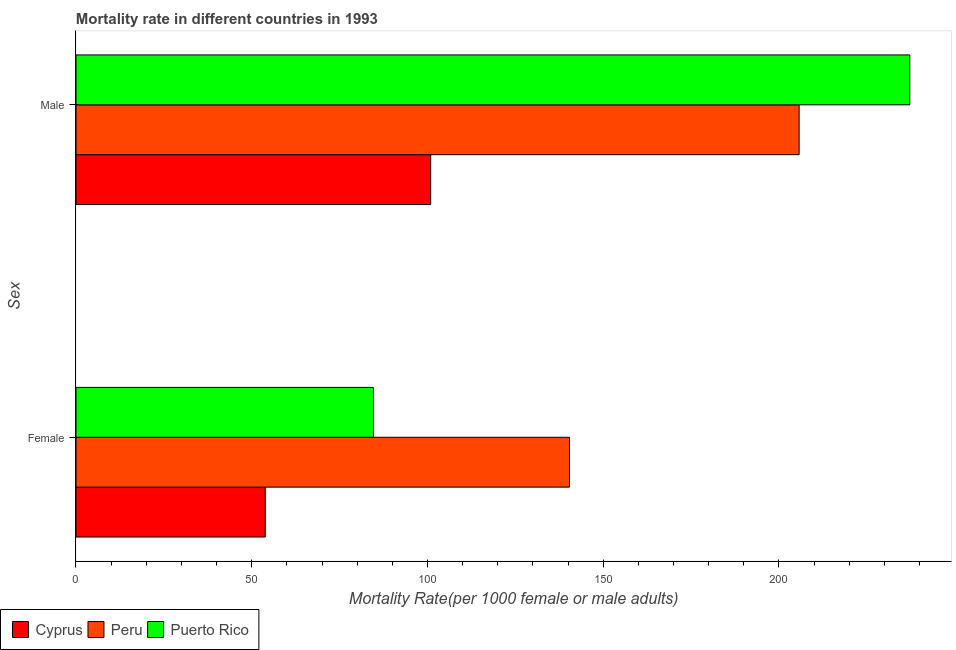Are the number of bars per tick equal to the number of legend labels?
Keep it short and to the point. Yes. Are the number of bars on each tick of the Y-axis equal?
Your answer should be compact. Yes. How many bars are there on the 1st tick from the bottom?
Your answer should be very brief. 3. What is the label of the 2nd group of bars from the top?
Make the answer very short. Female. What is the female mortality rate in Cyprus?
Ensure brevity in your answer.  53.86. Across all countries, what is the maximum male mortality rate?
Your response must be concise. 237.24. Across all countries, what is the minimum male mortality rate?
Make the answer very short. 100.92. In which country was the male mortality rate maximum?
Offer a terse response. Puerto Rico. In which country was the female mortality rate minimum?
Keep it short and to the point. Cyprus. What is the total female mortality rate in the graph?
Offer a terse response. 278.9. What is the difference between the female mortality rate in Puerto Rico and that in Peru?
Your answer should be compact. -55.78. What is the difference between the female mortality rate in Cyprus and the male mortality rate in Peru?
Offer a very short reply. -151.9. What is the average male mortality rate per country?
Provide a succinct answer. 181.31. What is the difference between the male mortality rate and female mortality rate in Peru?
Your answer should be very brief. 65.34. What is the ratio of the female mortality rate in Puerto Rico to that in Peru?
Offer a very short reply. 0.6. Is the male mortality rate in Peru less than that in Puerto Rico?
Keep it short and to the point. Yes. What does the 2nd bar from the top in Male represents?
Keep it short and to the point. Peru. What does the 1st bar from the bottom in Female represents?
Provide a succinct answer. Cyprus. How many bars are there?
Your answer should be compact. 6. How many countries are there in the graph?
Your response must be concise. 3. Does the graph contain grids?
Provide a succinct answer. No. How many legend labels are there?
Keep it short and to the point. 3. How are the legend labels stacked?
Provide a short and direct response. Horizontal. What is the title of the graph?
Ensure brevity in your answer.  Mortality rate in different countries in 1993. Does "Italy" appear as one of the legend labels in the graph?
Ensure brevity in your answer.  No. What is the label or title of the X-axis?
Ensure brevity in your answer.  Mortality Rate(per 1000 female or male adults). What is the label or title of the Y-axis?
Offer a very short reply. Sex. What is the Mortality Rate(per 1000 female or male adults) in Cyprus in Female?
Your answer should be compact. 53.86. What is the Mortality Rate(per 1000 female or male adults) in Peru in Female?
Your answer should be very brief. 140.41. What is the Mortality Rate(per 1000 female or male adults) of Puerto Rico in Female?
Keep it short and to the point. 84.63. What is the Mortality Rate(per 1000 female or male adults) of Cyprus in Male?
Make the answer very short. 100.92. What is the Mortality Rate(per 1000 female or male adults) of Peru in Male?
Your response must be concise. 205.76. What is the Mortality Rate(per 1000 female or male adults) of Puerto Rico in Male?
Offer a terse response. 237.24. Across all Sex, what is the maximum Mortality Rate(per 1000 female or male adults) of Cyprus?
Your answer should be very brief. 100.92. Across all Sex, what is the maximum Mortality Rate(per 1000 female or male adults) in Peru?
Give a very brief answer. 205.76. Across all Sex, what is the maximum Mortality Rate(per 1000 female or male adults) of Puerto Rico?
Your answer should be compact. 237.24. Across all Sex, what is the minimum Mortality Rate(per 1000 female or male adults) in Cyprus?
Provide a succinct answer. 53.86. Across all Sex, what is the minimum Mortality Rate(per 1000 female or male adults) in Peru?
Your answer should be very brief. 140.41. Across all Sex, what is the minimum Mortality Rate(per 1000 female or male adults) in Puerto Rico?
Your answer should be compact. 84.63. What is the total Mortality Rate(per 1000 female or male adults) in Cyprus in the graph?
Keep it short and to the point. 154.78. What is the total Mortality Rate(per 1000 female or male adults) of Peru in the graph?
Your answer should be very brief. 346.17. What is the total Mortality Rate(per 1000 female or male adults) in Puerto Rico in the graph?
Your response must be concise. 321.88. What is the difference between the Mortality Rate(per 1000 female or male adults) in Cyprus in Female and that in Male?
Provide a succinct answer. -47.06. What is the difference between the Mortality Rate(per 1000 female or male adults) of Peru in Female and that in Male?
Ensure brevity in your answer.  -65.34. What is the difference between the Mortality Rate(per 1000 female or male adults) in Puerto Rico in Female and that in Male?
Your answer should be very brief. -152.61. What is the difference between the Mortality Rate(per 1000 female or male adults) of Cyprus in Female and the Mortality Rate(per 1000 female or male adults) of Peru in Male?
Give a very brief answer. -151.9. What is the difference between the Mortality Rate(per 1000 female or male adults) in Cyprus in Female and the Mortality Rate(per 1000 female or male adults) in Puerto Rico in Male?
Provide a short and direct response. -183.39. What is the difference between the Mortality Rate(per 1000 female or male adults) of Peru in Female and the Mortality Rate(per 1000 female or male adults) of Puerto Rico in Male?
Your answer should be compact. -96.83. What is the average Mortality Rate(per 1000 female or male adults) of Cyprus per Sex?
Your answer should be compact. 77.39. What is the average Mortality Rate(per 1000 female or male adults) in Peru per Sex?
Provide a short and direct response. 173.08. What is the average Mortality Rate(per 1000 female or male adults) in Puerto Rico per Sex?
Your answer should be compact. 160.94. What is the difference between the Mortality Rate(per 1000 female or male adults) of Cyprus and Mortality Rate(per 1000 female or male adults) of Peru in Female?
Offer a terse response. -86.56. What is the difference between the Mortality Rate(per 1000 female or male adults) in Cyprus and Mortality Rate(per 1000 female or male adults) in Puerto Rico in Female?
Keep it short and to the point. -30.78. What is the difference between the Mortality Rate(per 1000 female or male adults) of Peru and Mortality Rate(per 1000 female or male adults) of Puerto Rico in Female?
Keep it short and to the point. 55.78. What is the difference between the Mortality Rate(per 1000 female or male adults) in Cyprus and Mortality Rate(per 1000 female or male adults) in Peru in Male?
Ensure brevity in your answer.  -104.84. What is the difference between the Mortality Rate(per 1000 female or male adults) of Cyprus and Mortality Rate(per 1000 female or male adults) of Puerto Rico in Male?
Your answer should be very brief. -136.32. What is the difference between the Mortality Rate(per 1000 female or male adults) in Peru and Mortality Rate(per 1000 female or male adults) in Puerto Rico in Male?
Your response must be concise. -31.49. What is the ratio of the Mortality Rate(per 1000 female or male adults) of Cyprus in Female to that in Male?
Offer a very short reply. 0.53. What is the ratio of the Mortality Rate(per 1000 female or male adults) of Peru in Female to that in Male?
Ensure brevity in your answer.  0.68. What is the ratio of the Mortality Rate(per 1000 female or male adults) in Puerto Rico in Female to that in Male?
Ensure brevity in your answer.  0.36. What is the difference between the highest and the second highest Mortality Rate(per 1000 female or male adults) in Cyprus?
Keep it short and to the point. 47.06. What is the difference between the highest and the second highest Mortality Rate(per 1000 female or male adults) in Peru?
Your answer should be very brief. 65.34. What is the difference between the highest and the second highest Mortality Rate(per 1000 female or male adults) of Puerto Rico?
Keep it short and to the point. 152.61. What is the difference between the highest and the lowest Mortality Rate(per 1000 female or male adults) of Cyprus?
Provide a succinct answer. 47.06. What is the difference between the highest and the lowest Mortality Rate(per 1000 female or male adults) in Peru?
Make the answer very short. 65.34. What is the difference between the highest and the lowest Mortality Rate(per 1000 female or male adults) of Puerto Rico?
Your answer should be very brief. 152.61. 